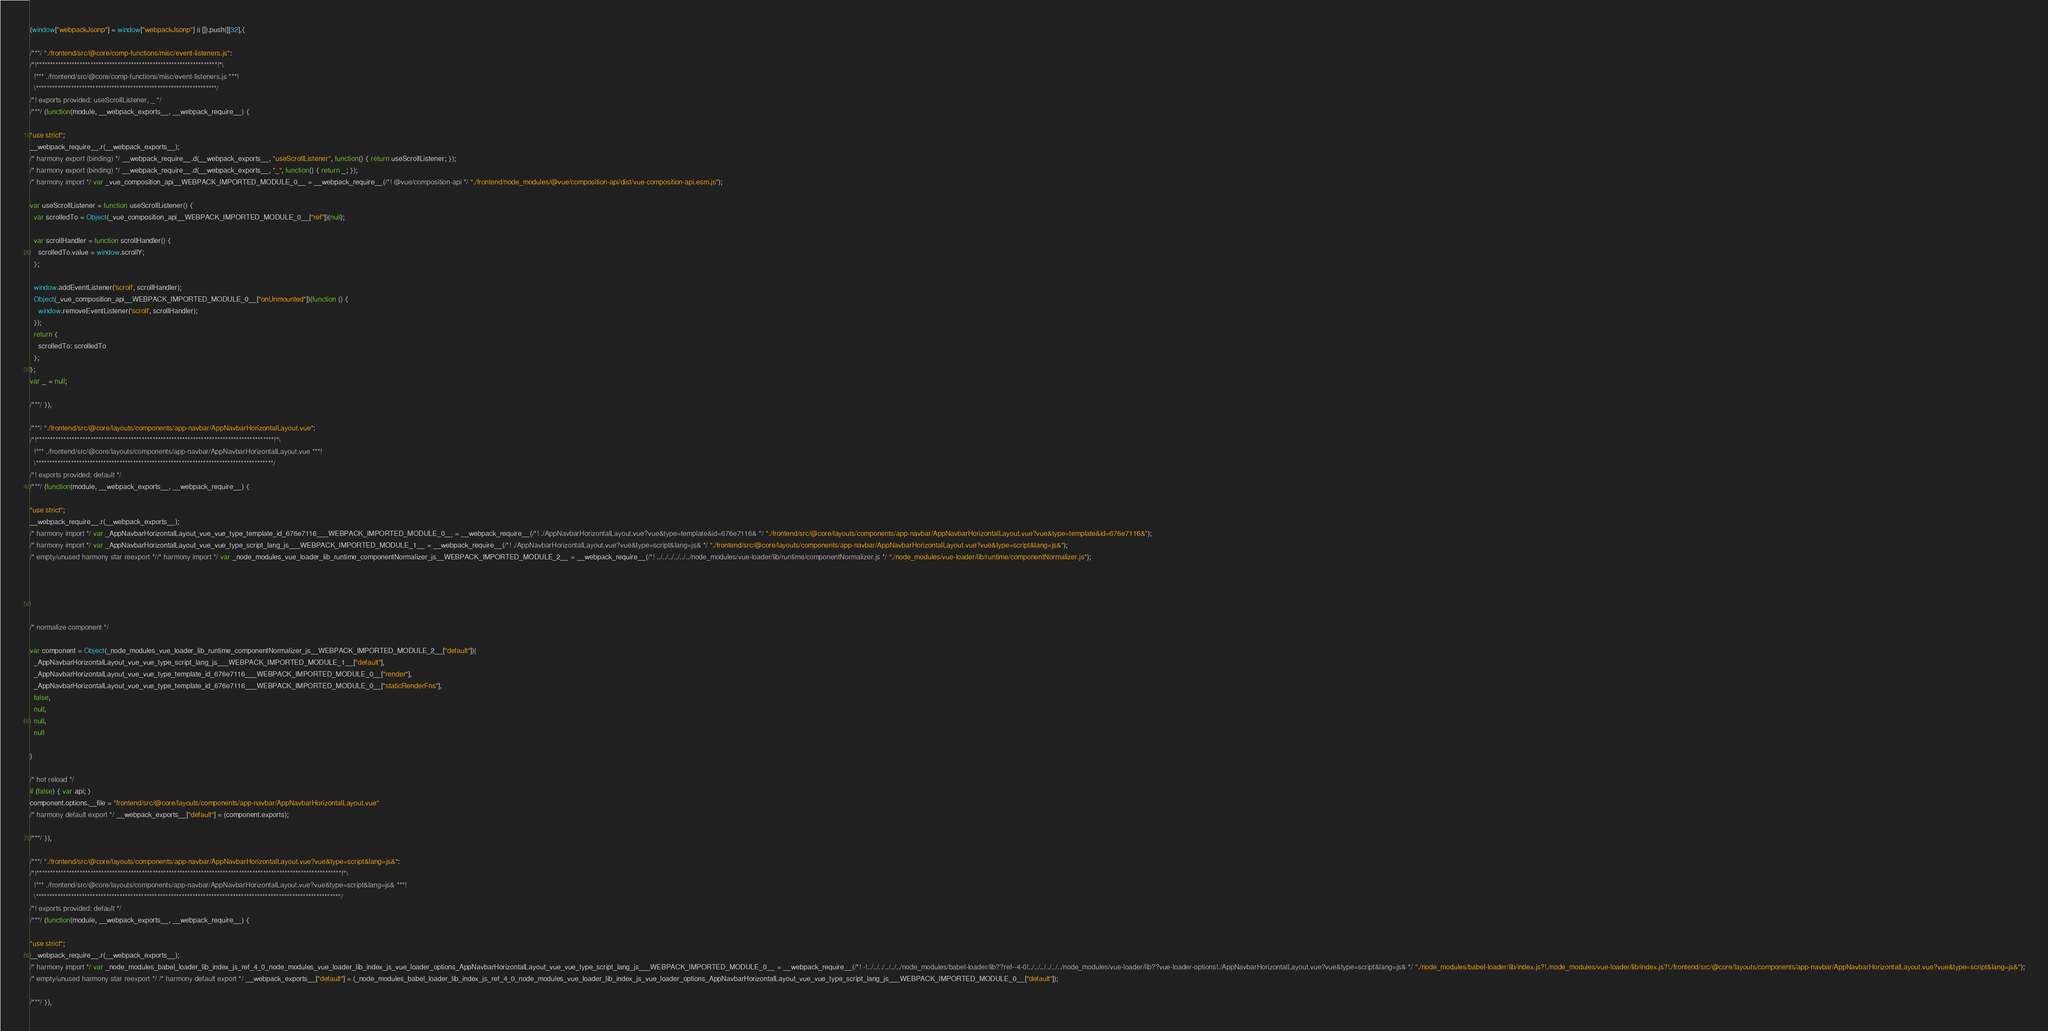<code> <loc_0><loc_0><loc_500><loc_500><_JavaScript_>(window["webpackJsonp"] = window["webpackJsonp"] || []).push([[32],{

/***/ "./frontend/src/@core/comp-functions/misc/event-listeners.js":
/*!*******************************************************************!*\
  !*** ./frontend/src/@core/comp-functions/misc/event-listeners.js ***!
  \*******************************************************************/
/*! exports provided: useScrollListener, _ */
/***/ (function(module, __webpack_exports__, __webpack_require__) {

"use strict";
__webpack_require__.r(__webpack_exports__);
/* harmony export (binding) */ __webpack_require__.d(__webpack_exports__, "useScrollListener", function() { return useScrollListener; });
/* harmony export (binding) */ __webpack_require__.d(__webpack_exports__, "_", function() { return _; });
/* harmony import */ var _vue_composition_api__WEBPACK_IMPORTED_MODULE_0__ = __webpack_require__(/*! @vue/composition-api */ "./frontend/node_modules/@vue/composition-api/dist/vue-composition-api.esm.js");

var useScrollListener = function useScrollListener() {
  var scrolledTo = Object(_vue_composition_api__WEBPACK_IMPORTED_MODULE_0__["ref"])(null);

  var scrollHandler = function scrollHandler() {
    scrolledTo.value = window.scrollY;
  };

  window.addEventListener('scroll', scrollHandler);
  Object(_vue_composition_api__WEBPACK_IMPORTED_MODULE_0__["onUnmounted"])(function () {
    window.removeEventListener('scroll', scrollHandler);
  });
  return {
    scrolledTo: scrolledTo
  };
};
var _ = null;

/***/ }),

/***/ "./frontend/src/@core/layouts/components/app-navbar/AppNavbarHorizontalLayout.vue":
/*!****************************************************************************************!*\
  !*** ./frontend/src/@core/layouts/components/app-navbar/AppNavbarHorizontalLayout.vue ***!
  \****************************************************************************************/
/*! exports provided: default */
/***/ (function(module, __webpack_exports__, __webpack_require__) {

"use strict";
__webpack_require__.r(__webpack_exports__);
/* harmony import */ var _AppNavbarHorizontalLayout_vue_vue_type_template_id_676e7116___WEBPACK_IMPORTED_MODULE_0__ = __webpack_require__(/*! ./AppNavbarHorizontalLayout.vue?vue&type=template&id=676e7116& */ "./frontend/src/@core/layouts/components/app-navbar/AppNavbarHorizontalLayout.vue?vue&type=template&id=676e7116&");
/* harmony import */ var _AppNavbarHorizontalLayout_vue_vue_type_script_lang_js___WEBPACK_IMPORTED_MODULE_1__ = __webpack_require__(/*! ./AppNavbarHorizontalLayout.vue?vue&type=script&lang=js& */ "./frontend/src/@core/layouts/components/app-navbar/AppNavbarHorizontalLayout.vue?vue&type=script&lang=js&");
/* empty/unused harmony star reexport *//* harmony import */ var _node_modules_vue_loader_lib_runtime_componentNormalizer_js__WEBPACK_IMPORTED_MODULE_2__ = __webpack_require__(/*! ../../../../../../node_modules/vue-loader/lib/runtime/componentNormalizer.js */ "./node_modules/vue-loader/lib/runtime/componentNormalizer.js");





/* normalize component */

var component = Object(_node_modules_vue_loader_lib_runtime_componentNormalizer_js__WEBPACK_IMPORTED_MODULE_2__["default"])(
  _AppNavbarHorizontalLayout_vue_vue_type_script_lang_js___WEBPACK_IMPORTED_MODULE_1__["default"],
  _AppNavbarHorizontalLayout_vue_vue_type_template_id_676e7116___WEBPACK_IMPORTED_MODULE_0__["render"],
  _AppNavbarHorizontalLayout_vue_vue_type_template_id_676e7116___WEBPACK_IMPORTED_MODULE_0__["staticRenderFns"],
  false,
  null,
  null,
  null
  
)

/* hot reload */
if (false) { var api; }
component.options.__file = "frontend/src/@core/layouts/components/app-navbar/AppNavbarHorizontalLayout.vue"
/* harmony default export */ __webpack_exports__["default"] = (component.exports);

/***/ }),

/***/ "./frontend/src/@core/layouts/components/app-navbar/AppNavbarHorizontalLayout.vue?vue&type=script&lang=js&":
/*!*****************************************************************************************************************!*\
  !*** ./frontend/src/@core/layouts/components/app-navbar/AppNavbarHorizontalLayout.vue?vue&type=script&lang=js& ***!
  \*****************************************************************************************************************/
/*! exports provided: default */
/***/ (function(module, __webpack_exports__, __webpack_require__) {

"use strict";
__webpack_require__.r(__webpack_exports__);
/* harmony import */ var _node_modules_babel_loader_lib_index_js_ref_4_0_node_modules_vue_loader_lib_index_js_vue_loader_options_AppNavbarHorizontalLayout_vue_vue_type_script_lang_js___WEBPACK_IMPORTED_MODULE_0__ = __webpack_require__(/*! -!../../../../../../node_modules/babel-loader/lib??ref--4-0!../../../../../../node_modules/vue-loader/lib??vue-loader-options!./AppNavbarHorizontalLayout.vue?vue&type=script&lang=js& */ "./node_modules/babel-loader/lib/index.js?!./node_modules/vue-loader/lib/index.js?!./frontend/src/@core/layouts/components/app-navbar/AppNavbarHorizontalLayout.vue?vue&type=script&lang=js&");
/* empty/unused harmony star reexport */ /* harmony default export */ __webpack_exports__["default"] = (_node_modules_babel_loader_lib_index_js_ref_4_0_node_modules_vue_loader_lib_index_js_vue_loader_options_AppNavbarHorizontalLayout_vue_vue_type_script_lang_js___WEBPACK_IMPORTED_MODULE_0__["default"]); 

/***/ }),
</code> 